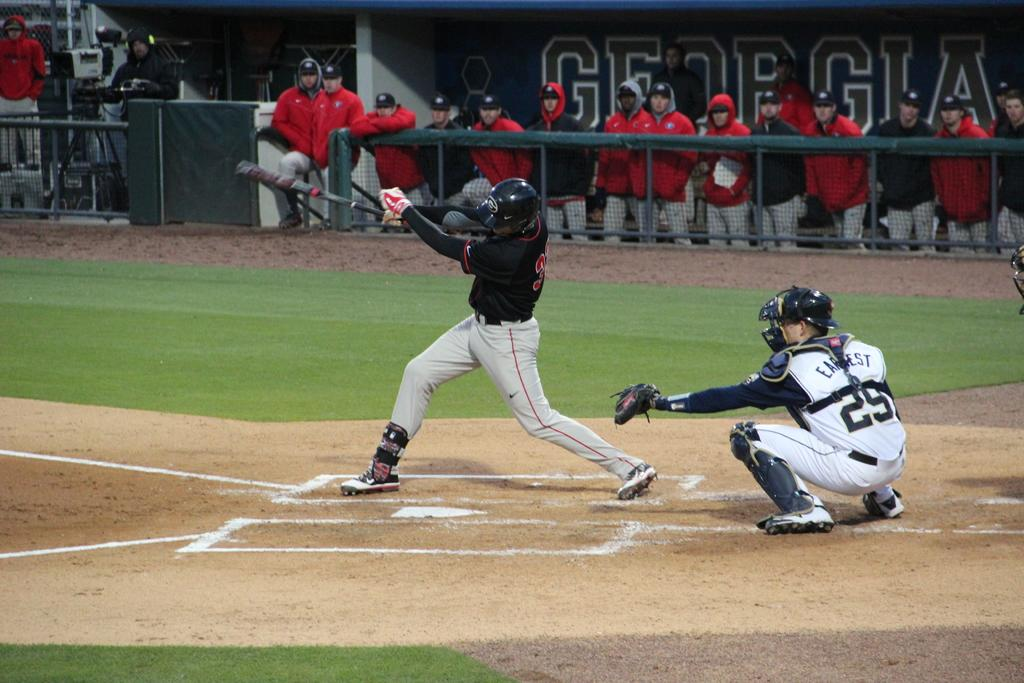<image>
Present a compact description of the photo's key features. Two baseball players, one wearing the number 29 on the back of their shirt 